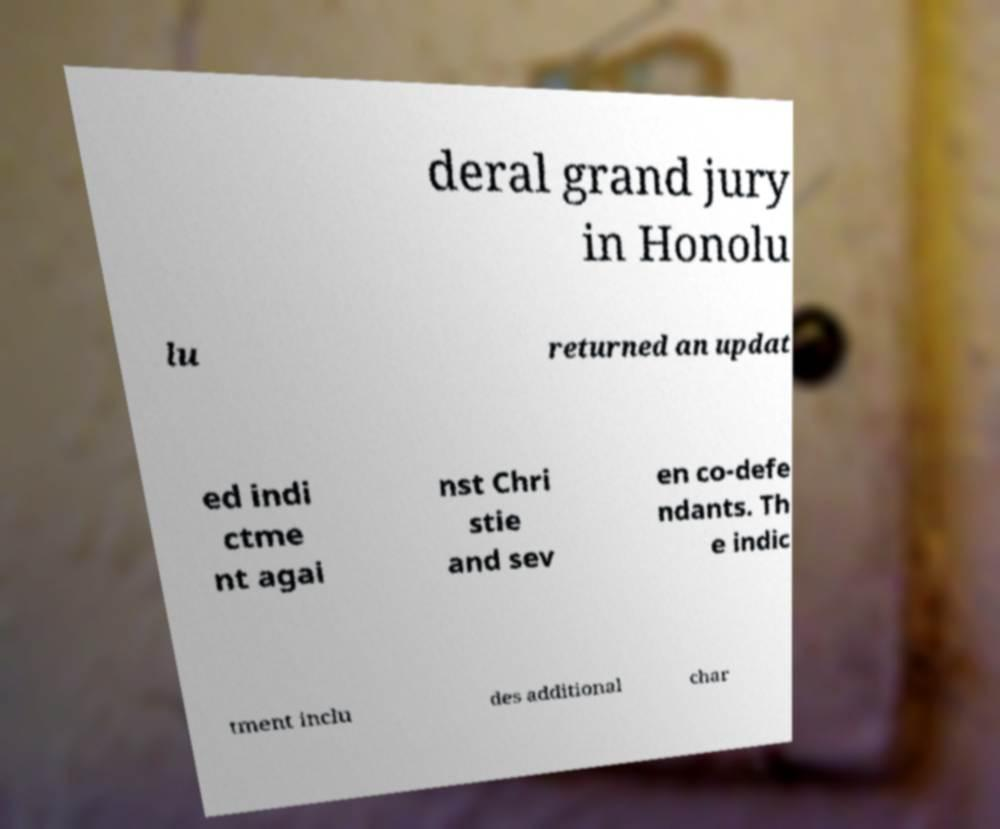Please read and relay the text visible in this image. What does it say? deral grand jury in Honolu lu returned an updat ed indi ctme nt agai nst Chri stie and sev en co-defe ndants. Th e indic tment inclu des additional char 